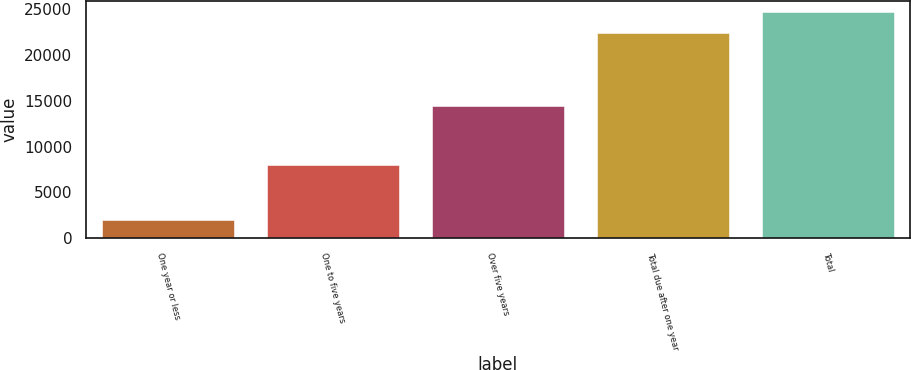Convert chart. <chart><loc_0><loc_0><loc_500><loc_500><bar_chart><fcel>One year or less<fcel>One to five years<fcel>Over five years<fcel>Total due after one year<fcel>Total<nl><fcel>1946.2<fcel>7990<fcel>14454.1<fcel>22444.1<fcel>24688.5<nl></chart> 